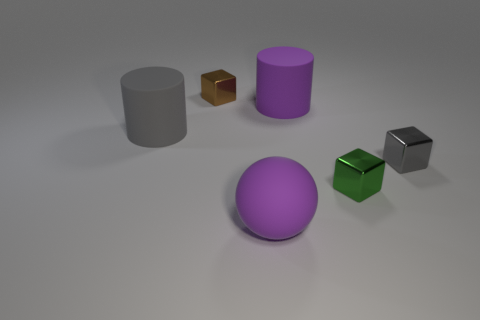Subtract all red cubes. Subtract all red cylinders. How many cubes are left? 3 Add 4 cyan rubber spheres. How many objects exist? 10 Subtract all balls. How many objects are left? 5 Subtract all shiny objects. Subtract all cyan metallic balls. How many objects are left? 3 Add 2 big objects. How many big objects are left? 5 Add 2 big matte cylinders. How many big matte cylinders exist? 4 Subtract 0 cyan cylinders. How many objects are left? 6 